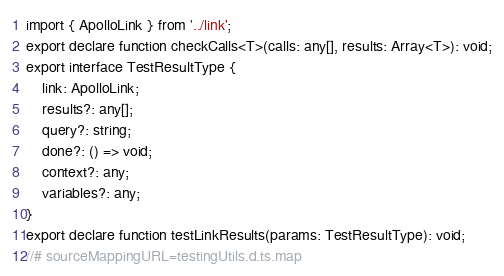<code> <loc_0><loc_0><loc_500><loc_500><_TypeScript_>import { ApolloLink } from '../link';
export declare function checkCalls<T>(calls: any[], results: Array<T>): void;
export interface TestResultType {
    link: ApolloLink;
    results?: any[];
    query?: string;
    done?: () => void;
    context?: any;
    variables?: any;
}
export declare function testLinkResults(params: TestResultType): void;
//# sourceMappingURL=testingUtils.d.ts.map</code> 